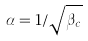Convert formula to latex. <formula><loc_0><loc_0><loc_500><loc_500>\alpha = 1 / \sqrt { \beta _ { c } }</formula> 